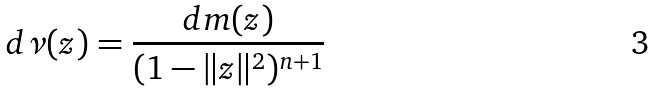<formula> <loc_0><loc_0><loc_500><loc_500>d \nu ( z ) = \frac { d m ( z ) } { ( 1 - \| z \| ^ { 2 } ) ^ { n + 1 } }</formula> 